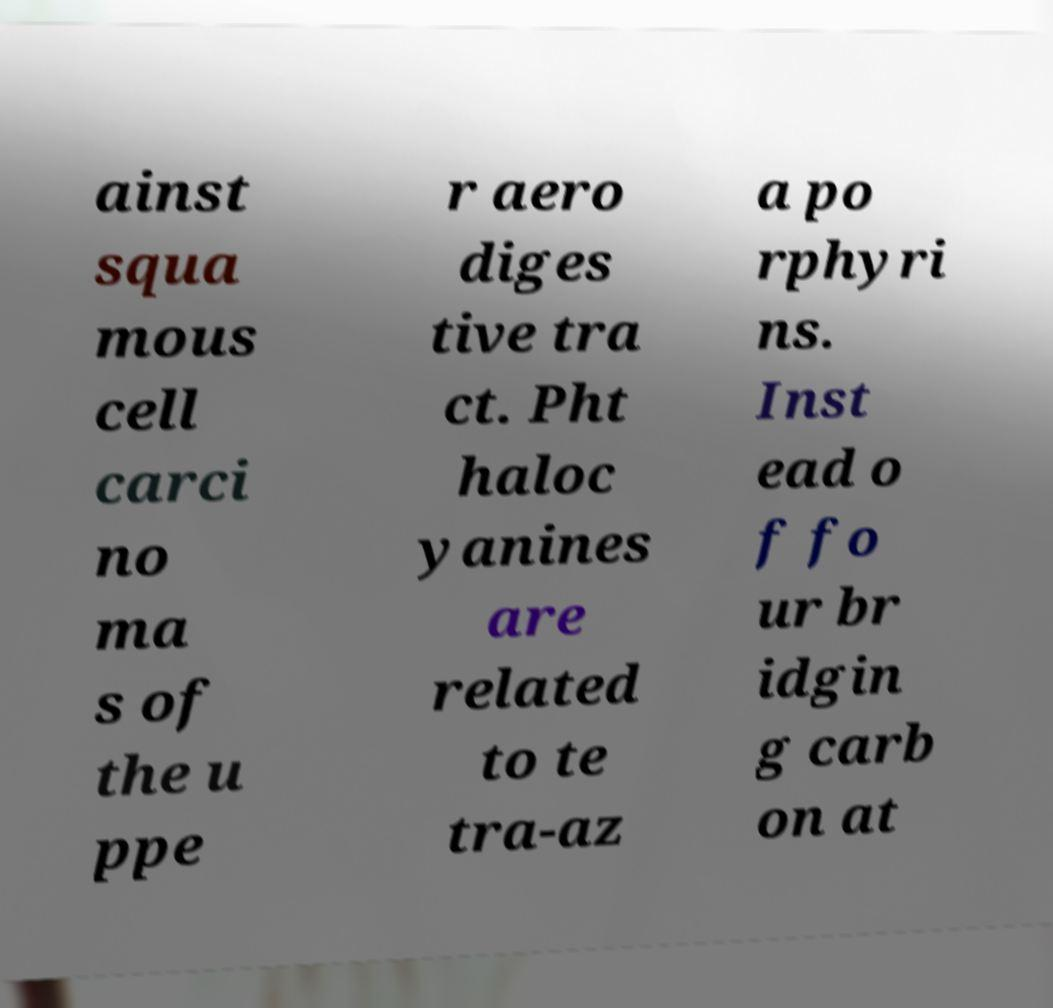For documentation purposes, I need the text within this image transcribed. Could you provide that? ainst squa mous cell carci no ma s of the u ppe r aero diges tive tra ct. Pht haloc yanines are related to te tra-az a po rphyri ns. Inst ead o f fo ur br idgin g carb on at 